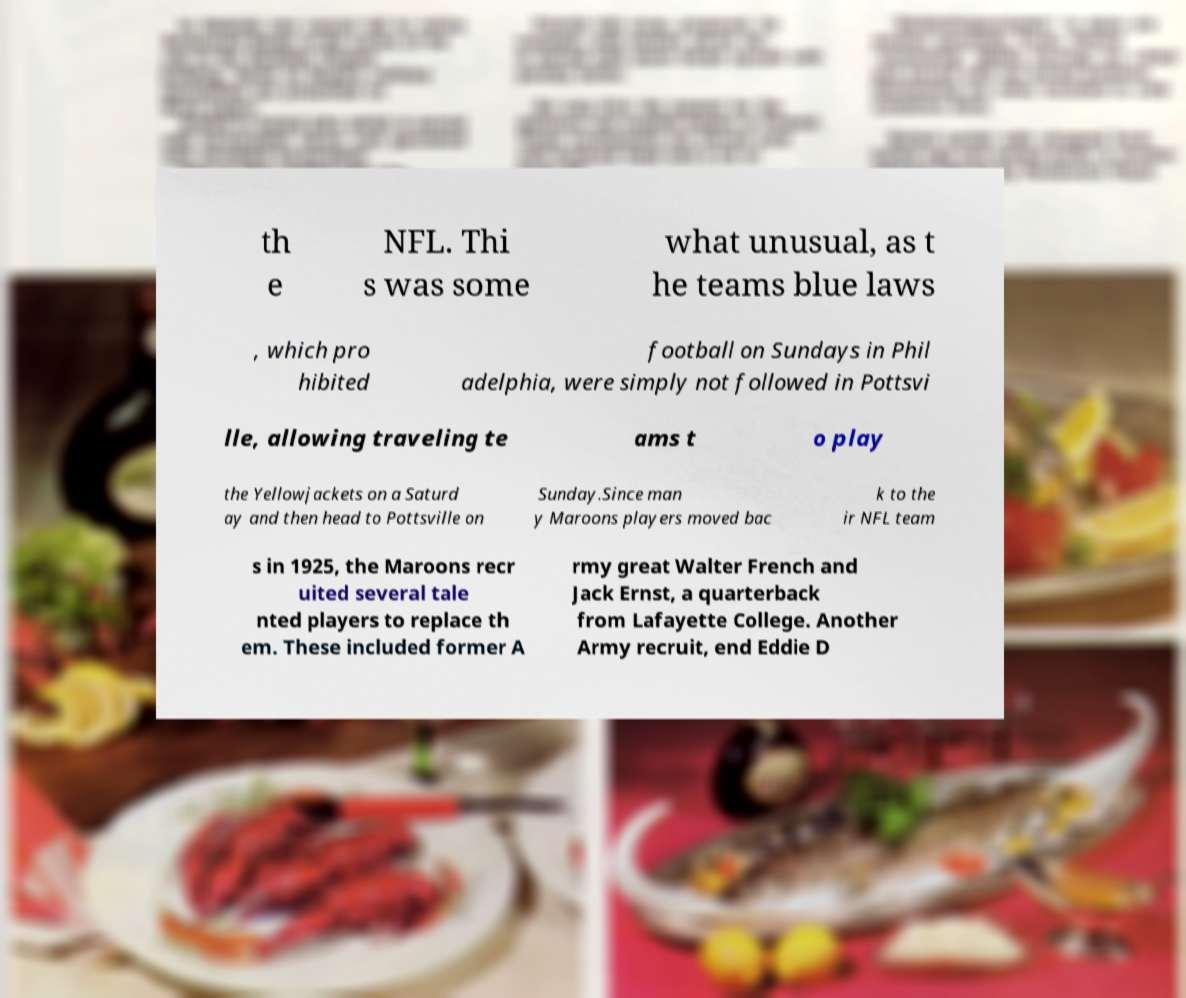What messages or text are displayed in this image? I need them in a readable, typed format. th e NFL. Thi s was some what unusual, as t he teams blue laws , which pro hibited football on Sundays in Phil adelphia, were simply not followed in Pottsvi lle, allowing traveling te ams t o play the Yellowjackets on a Saturd ay and then head to Pottsville on Sunday.Since man y Maroons players moved bac k to the ir NFL team s in 1925, the Maroons recr uited several tale nted players to replace th em. These included former A rmy great Walter French and Jack Ernst, a quarterback from Lafayette College. Another Army recruit, end Eddie D 